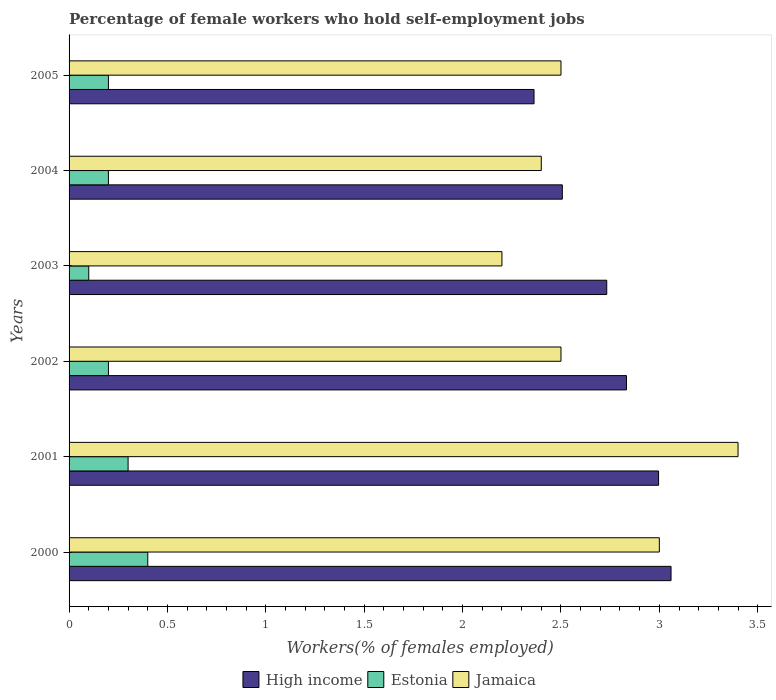How many different coloured bars are there?
Keep it short and to the point. 3. Are the number of bars on each tick of the Y-axis equal?
Your answer should be compact. Yes. How many bars are there on the 4th tick from the bottom?
Your answer should be compact. 3. In how many cases, is the number of bars for a given year not equal to the number of legend labels?
Make the answer very short. 0. What is the percentage of self-employed female workers in High income in 2005?
Offer a terse response. 2.36. Across all years, what is the maximum percentage of self-employed female workers in Estonia?
Your answer should be very brief. 0.4. Across all years, what is the minimum percentage of self-employed female workers in Jamaica?
Make the answer very short. 2.2. What is the total percentage of self-employed female workers in Jamaica in the graph?
Ensure brevity in your answer.  16. What is the difference between the percentage of self-employed female workers in Jamaica in 2004 and that in 2005?
Keep it short and to the point. -0.1. What is the difference between the percentage of self-employed female workers in High income in 2000 and the percentage of self-employed female workers in Jamaica in 2003?
Ensure brevity in your answer.  0.86. What is the average percentage of self-employed female workers in High income per year?
Give a very brief answer. 2.75. In the year 2003, what is the difference between the percentage of self-employed female workers in Estonia and percentage of self-employed female workers in High income?
Keep it short and to the point. -2.63. In how many years, is the percentage of self-employed female workers in Estonia greater than 1.1 %?
Make the answer very short. 0. What is the ratio of the percentage of self-employed female workers in High income in 2000 to that in 2005?
Offer a terse response. 1.29. Is the percentage of self-employed female workers in Jamaica in 2002 less than that in 2003?
Ensure brevity in your answer.  No. What is the difference between the highest and the second highest percentage of self-employed female workers in Estonia?
Offer a terse response. 0.1. What is the difference between the highest and the lowest percentage of self-employed female workers in Estonia?
Keep it short and to the point. 0.3. In how many years, is the percentage of self-employed female workers in Estonia greater than the average percentage of self-employed female workers in Estonia taken over all years?
Give a very brief answer. 2. What does the 1st bar from the top in 2005 represents?
Offer a terse response. Jamaica. What does the 3rd bar from the bottom in 2003 represents?
Your answer should be very brief. Jamaica. Is it the case that in every year, the sum of the percentage of self-employed female workers in Estonia and percentage of self-employed female workers in Jamaica is greater than the percentage of self-employed female workers in High income?
Keep it short and to the point. No. Are all the bars in the graph horizontal?
Offer a very short reply. Yes. What is the difference between two consecutive major ticks on the X-axis?
Provide a succinct answer. 0.5. Are the values on the major ticks of X-axis written in scientific E-notation?
Your answer should be compact. No. Does the graph contain any zero values?
Your answer should be very brief. No. Does the graph contain grids?
Ensure brevity in your answer.  No. What is the title of the graph?
Offer a very short reply. Percentage of female workers who hold self-employment jobs. Does "Netherlands" appear as one of the legend labels in the graph?
Offer a terse response. No. What is the label or title of the X-axis?
Give a very brief answer. Workers(% of females employed). What is the label or title of the Y-axis?
Your answer should be very brief. Years. What is the Workers(% of females employed) in High income in 2000?
Your response must be concise. 3.06. What is the Workers(% of females employed) in Estonia in 2000?
Ensure brevity in your answer.  0.4. What is the Workers(% of females employed) of Jamaica in 2000?
Your response must be concise. 3. What is the Workers(% of females employed) of High income in 2001?
Your answer should be compact. 3. What is the Workers(% of females employed) in Estonia in 2001?
Keep it short and to the point. 0.3. What is the Workers(% of females employed) of Jamaica in 2001?
Keep it short and to the point. 3.4. What is the Workers(% of females employed) of High income in 2002?
Make the answer very short. 2.83. What is the Workers(% of females employed) in Estonia in 2002?
Ensure brevity in your answer.  0.2. What is the Workers(% of females employed) in High income in 2003?
Ensure brevity in your answer.  2.73. What is the Workers(% of females employed) in Estonia in 2003?
Provide a short and direct response. 0.1. What is the Workers(% of females employed) in Jamaica in 2003?
Your response must be concise. 2.2. What is the Workers(% of females employed) in High income in 2004?
Provide a succinct answer. 2.51. What is the Workers(% of females employed) of Estonia in 2004?
Your answer should be compact. 0.2. What is the Workers(% of females employed) of Jamaica in 2004?
Your answer should be very brief. 2.4. What is the Workers(% of females employed) in High income in 2005?
Make the answer very short. 2.36. What is the Workers(% of females employed) in Estonia in 2005?
Ensure brevity in your answer.  0.2. What is the Workers(% of females employed) of Jamaica in 2005?
Your answer should be very brief. 2.5. Across all years, what is the maximum Workers(% of females employed) of High income?
Provide a succinct answer. 3.06. Across all years, what is the maximum Workers(% of females employed) of Estonia?
Your response must be concise. 0.4. Across all years, what is the maximum Workers(% of females employed) of Jamaica?
Make the answer very short. 3.4. Across all years, what is the minimum Workers(% of females employed) in High income?
Provide a succinct answer. 2.36. Across all years, what is the minimum Workers(% of females employed) in Estonia?
Make the answer very short. 0.1. Across all years, what is the minimum Workers(% of females employed) of Jamaica?
Your answer should be compact. 2.2. What is the total Workers(% of females employed) of High income in the graph?
Provide a succinct answer. 16.49. What is the difference between the Workers(% of females employed) in High income in 2000 and that in 2001?
Keep it short and to the point. 0.06. What is the difference between the Workers(% of females employed) of High income in 2000 and that in 2002?
Your answer should be compact. 0.23. What is the difference between the Workers(% of females employed) of Estonia in 2000 and that in 2002?
Make the answer very short. 0.2. What is the difference between the Workers(% of females employed) of Jamaica in 2000 and that in 2002?
Ensure brevity in your answer.  0.5. What is the difference between the Workers(% of females employed) in High income in 2000 and that in 2003?
Your response must be concise. 0.33. What is the difference between the Workers(% of females employed) in High income in 2000 and that in 2004?
Keep it short and to the point. 0.55. What is the difference between the Workers(% of females employed) in Estonia in 2000 and that in 2004?
Offer a terse response. 0.2. What is the difference between the Workers(% of females employed) in Jamaica in 2000 and that in 2004?
Provide a short and direct response. 0.6. What is the difference between the Workers(% of females employed) in High income in 2000 and that in 2005?
Your response must be concise. 0.7. What is the difference between the Workers(% of females employed) in Estonia in 2000 and that in 2005?
Give a very brief answer. 0.2. What is the difference between the Workers(% of females employed) of High income in 2001 and that in 2002?
Offer a very short reply. 0.16. What is the difference between the Workers(% of females employed) in Jamaica in 2001 and that in 2002?
Offer a very short reply. 0.9. What is the difference between the Workers(% of females employed) in High income in 2001 and that in 2003?
Your response must be concise. 0.26. What is the difference between the Workers(% of females employed) of High income in 2001 and that in 2004?
Provide a short and direct response. 0.49. What is the difference between the Workers(% of females employed) of High income in 2001 and that in 2005?
Your answer should be very brief. 0.63. What is the difference between the Workers(% of females employed) in Jamaica in 2001 and that in 2005?
Make the answer very short. 0.9. What is the difference between the Workers(% of females employed) of High income in 2002 and that in 2003?
Provide a short and direct response. 0.1. What is the difference between the Workers(% of females employed) of Estonia in 2002 and that in 2003?
Offer a very short reply. 0.1. What is the difference between the Workers(% of females employed) in High income in 2002 and that in 2004?
Your answer should be very brief. 0.33. What is the difference between the Workers(% of females employed) in Estonia in 2002 and that in 2004?
Your response must be concise. 0. What is the difference between the Workers(% of females employed) of Jamaica in 2002 and that in 2004?
Your answer should be very brief. 0.1. What is the difference between the Workers(% of females employed) of High income in 2002 and that in 2005?
Make the answer very short. 0.47. What is the difference between the Workers(% of females employed) in Estonia in 2002 and that in 2005?
Offer a terse response. 0. What is the difference between the Workers(% of females employed) in Jamaica in 2002 and that in 2005?
Make the answer very short. 0. What is the difference between the Workers(% of females employed) of High income in 2003 and that in 2004?
Offer a terse response. 0.23. What is the difference between the Workers(% of females employed) of Estonia in 2003 and that in 2004?
Your answer should be compact. -0.1. What is the difference between the Workers(% of females employed) in Jamaica in 2003 and that in 2004?
Offer a very short reply. -0.2. What is the difference between the Workers(% of females employed) of High income in 2003 and that in 2005?
Your response must be concise. 0.37. What is the difference between the Workers(% of females employed) of High income in 2004 and that in 2005?
Provide a short and direct response. 0.14. What is the difference between the Workers(% of females employed) of High income in 2000 and the Workers(% of females employed) of Estonia in 2001?
Provide a short and direct response. 2.76. What is the difference between the Workers(% of females employed) in High income in 2000 and the Workers(% of females employed) in Jamaica in 2001?
Your answer should be very brief. -0.34. What is the difference between the Workers(% of females employed) of High income in 2000 and the Workers(% of females employed) of Estonia in 2002?
Your answer should be very brief. 2.86. What is the difference between the Workers(% of females employed) in High income in 2000 and the Workers(% of females employed) in Jamaica in 2002?
Provide a short and direct response. 0.56. What is the difference between the Workers(% of females employed) of Estonia in 2000 and the Workers(% of females employed) of Jamaica in 2002?
Your answer should be compact. -2.1. What is the difference between the Workers(% of females employed) of High income in 2000 and the Workers(% of females employed) of Estonia in 2003?
Offer a terse response. 2.96. What is the difference between the Workers(% of females employed) in High income in 2000 and the Workers(% of females employed) in Jamaica in 2003?
Make the answer very short. 0.86. What is the difference between the Workers(% of females employed) in High income in 2000 and the Workers(% of females employed) in Estonia in 2004?
Your response must be concise. 2.86. What is the difference between the Workers(% of females employed) of High income in 2000 and the Workers(% of females employed) of Jamaica in 2004?
Keep it short and to the point. 0.66. What is the difference between the Workers(% of females employed) of High income in 2000 and the Workers(% of females employed) of Estonia in 2005?
Provide a succinct answer. 2.86. What is the difference between the Workers(% of females employed) of High income in 2000 and the Workers(% of females employed) of Jamaica in 2005?
Give a very brief answer. 0.56. What is the difference between the Workers(% of females employed) of Estonia in 2000 and the Workers(% of females employed) of Jamaica in 2005?
Offer a very short reply. -2.1. What is the difference between the Workers(% of females employed) in High income in 2001 and the Workers(% of females employed) in Estonia in 2002?
Provide a succinct answer. 2.8. What is the difference between the Workers(% of females employed) of High income in 2001 and the Workers(% of females employed) of Jamaica in 2002?
Your answer should be compact. 0.5. What is the difference between the Workers(% of females employed) in Estonia in 2001 and the Workers(% of females employed) in Jamaica in 2002?
Offer a very short reply. -2.2. What is the difference between the Workers(% of females employed) in High income in 2001 and the Workers(% of females employed) in Estonia in 2003?
Offer a terse response. 2.9. What is the difference between the Workers(% of females employed) in High income in 2001 and the Workers(% of females employed) in Jamaica in 2003?
Keep it short and to the point. 0.8. What is the difference between the Workers(% of females employed) in Estonia in 2001 and the Workers(% of females employed) in Jamaica in 2003?
Your answer should be compact. -1.9. What is the difference between the Workers(% of females employed) in High income in 2001 and the Workers(% of females employed) in Estonia in 2004?
Offer a terse response. 2.8. What is the difference between the Workers(% of females employed) in High income in 2001 and the Workers(% of females employed) in Jamaica in 2004?
Make the answer very short. 0.6. What is the difference between the Workers(% of females employed) of Estonia in 2001 and the Workers(% of females employed) of Jamaica in 2004?
Give a very brief answer. -2.1. What is the difference between the Workers(% of females employed) in High income in 2001 and the Workers(% of females employed) in Estonia in 2005?
Offer a very short reply. 2.8. What is the difference between the Workers(% of females employed) of High income in 2001 and the Workers(% of females employed) of Jamaica in 2005?
Provide a short and direct response. 0.5. What is the difference between the Workers(% of females employed) of High income in 2002 and the Workers(% of females employed) of Estonia in 2003?
Offer a very short reply. 2.73. What is the difference between the Workers(% of females employed) in High income in 2002 and the Workers(% of females employed) in Jamaica in 2003?
Make the answer very short. 0.63. What is the difference between the Workers(% of females employed) of High income in 2002 and the Workers(% of females employed) of Estonia in 2004?
Make the answer very short. 2.63. What is the difference between the Workers(% of females employed) in High income in 2002 and the Workers(% of females employed) in Jamaica in 2004?
Ensure brevity in your answer.  0.43. What is the difference between the Workers(% of females employed) in Estonia in 2002 and the Workers(% of females employed) in Jamaica in 2004?
Your answer should be very brief. -2.2. What is the difference between the Workers(% of females employed) of High income in 2002 and the Workers(% of females employed) of Estonia in 2005?
Provide a short and direct response. 2.63. What is the difference between the Workers(% of females employed) of High income in 2002 and the Workers(% of females employed) of Jamaica in 2005?
Keep it short and to the point. 0.33. What is the difference between the Workers(% of females employed) of High income in 2003 and the Workers(% of females employed) of Estonia in 2004?
Make the answer very short. 2.53. What is the difference between the Workers(% of females employed) in High income in 2003 and the Workers(% of females employed) in Jamaica in 2004?
Give a very brief answer. 0.33. What is the difference between the Workers(% of females employed) in Estonia in 2003 and the Workers(% of females employed) in Jamaica in 2004?
Your response must be concise. -2.3. What is the difference between the Workers(% of females employed) of High income in 2003 and the Workers(% of females employed) of Estonia in 2005?
Your answer should be compact. 2.53. What is the difference between the Workers(% of females employed) in High income in 2003 and the Workers(% of females employed) in Jamaica in 2005?
Your response must be concise. 0.23. What is the difference between the Workers(% of females employed) of High income in 2004 and the Workers(% of females employed) of Estonia in 2005?
Provide a succinct answer. 2.31. What is the difference between the Workers(% of females employed) in High income in 2004 and the Workers(% of females employed) in Jamaica in 2005?
Keep it short and to the point. 0.01. What is the average Workers(% of females employed) of High income per year?
Make the answer very short. 2.75. What is the average Workers(% of females employed) in Estonia per year?
Keep it short and to the point. 0.23. What is the average Workers(% of females employed) of Jamaica per year?
Your response must be concise. 2.67. In the year 2000, what is the difference between the Workers(% of females employed) of High income and Workers(% of females employed) of Estonia?
Keep it short and to the point. 2.66. In the year 2000, what is the difference between the Workers(% of females employed) in High income and Workers(% of females employed) in Jamaica?
Make the answer very short. 0.06. In the year 2000, what is the difference between the Workers(% of females employed) of Estonia and Workers(% of females employed) of Jamaica?
Give a very brief answer. -2.6. In the year 2001, what is the difference between the Workers(% of females employed) of High income and Workers(% of females employed) of Estonia?
Keep it short and to the point. 2.7. In the year 2001, what is the difference between the Workers(% of females employed) of High income and Workers(% of females employed) of Jamaica?
Make the answer very short. -0.4. In the year 2001, what is the difference between the Workers(% of females employed) of Estonia and Workers(% of females employed) of Jamaica?
Make the answer very short. -3.1. In the year 2002, what is the difference between the Workers(% of females employed) in High income and Workers(% of females employed) in Estonia?
Your answer should be very brief. 2.63. In the year 2002, what is the difference between the Workers(% of females employed) of High income and Workers(% of females employed) of Jamaica?
Your answer should be very brief. 0.33. In the year 2002, what is the difference between the Workers(% of females employed) in Estonia and Workers(% of females employed) in Jamaica?
Keep it short and to the point. -2.3. In the year 2003, what is the difference between the Workers(% of females employed) of High income and Workers(% of females employed) of Estonia?
Offer a very short reply. 2.63. In the year 2003, what is the difference between the Workers(% of females employed) in High income and Workers(% of females employed) in Jamaica?
Your response must be concise. 0.53. In the year 2004, what is the difference between the Workers(% of females employed) in High income and Workers(% of females employed) in Estonia?
Make the answer very short. 2.31. In the year 2004, what is the difference between the Workers(% of females employed) of High income and Workers(% of females employed) of Jamaica?
Keep it short and to the point. 0.11. In the year 2004, what is the difference between the Workers(% of females employed) of Estonia and Workers(% of females employed) of Jamaica?
Your response must be concise. -2.2. In the year 2005, what is the difference between the Workers(% of females employed) of High income and Workers(% of females employed) of Estonia?
Offer a very short reply. 2.16. In the year 2005, what is the difference between the Workers(% of females employed) in High income and Workers(% of females employed) in Jamaica?
Ensure brevity in your answer.  -0.14. What is the ratio of the Workers(% of females employed) in High income in 2000 to that in 2001?
Make the answer very short. 1.02. What is the ratio of the Workers(% of females employed) of Estonia in 2000 to that in 2001?
Provide a succinct answer. 1.33. What is the ratio of the Workers(% of females employed) of Jamaica in 2000 to that in 2001?
Your response must be concise. 0.88. What is the ratio of the Workers(% of females employed) of High income in 2000 to that in 2002?
Give a very brief answer. 1.08. What is the ratio of the Workers(% of females employed) in Estonia in 2000 to that in 2002?
Provide a succinct answer. 2. What is the ratio of the Workers(% of females employed) in High income in 2000 to that in 2003?
Give a very brief answer. 1.12. What is the ratio of the Workers(% of females employed) of Estonia in 2000 to that in 2003?
Your answer should be compact. 4. What is the ratio of the Workers(% of females employed) of Jamaica in 2000 to that in 2003?
Offer a terse response. 1.36. What is the ratio of the Workers(% of females employed) of High income in 2000 to that in 2004?
Your response must be concise. 1.22. What is the ratio of the Workers(% of females employed) in Jamaica in 2000 to that in 2004?
Your answer should be compact. 1.25. What is the ratio of the Workers(% of females employed) of High income in 2000 to that in 2005?
Your response must be concise. 1.29. What is the ratio of the Workers(% of females employed) of Jamaica in 2000 to that in 2005?
Make the answer very short. 1.2. What is the ratio of the Workers(% of females employed) of High income in 2001 to that in 2002?
Make the answer very short. 1.06. What is the ratio of the Workers(% of females employed) of Jamaica in 2001 to that in 2002?
Your answer should be compact. 1.36. What is the ratio of the Workers(% of females employed) of High income in 2001 to that in 2003?
Give a very brief answer. 1.1. What is the ratio of the Workers(% of females employed) in Jamaica in 2001 to that in 2003?
Provide a succinct answer. 1.55. What is the ratio of the Workers(% of females employed) in High income in 2001 to that in 2004?
Offer a very short reply. 1.2. What is the ratio of the Workers(% of females employed) of Estonia in 2001 to that in 2004?
Keep it short and to the point. 1.5. What is the ratio of the Workers(% of females employed) in Jamaica in 2001 to that in 2004?
Your answer should be very brief. 1.42. What is the ratio of the Workers(% of females employed) in High income in 2001 to that in 2005?
Your answer should be compact. 1.27. What is the ratio of the Workers(% of females employed) in Estonia in 2001 to that in 2005?
Offer a terse response. 1.5. What is the ratio of the Workers(% of females employed) of Jamaica in 2001 to that in 2005?
Your answer should be very brief. 1.36. What is the ratio of the Workers(% of females employed) of High income in 2002 to that in 2003?
Your answer should be compact. 1.04. What is the ratio of the Workers(% of females employed) in Jamaica in 2002 to that in 2003?
Offer a very short reply. 1.14. What is the ratio of the Workers(% of females employed) in High income in 2002 to that in 2004?
Your answer should be compact. 1.13. What is the ratio of the Workers(% of females employed) in Jamaica in 2002 to that in 2004?
Provide a short and direct response. 1.04. What is the ratio of the Workers(% of females employed) of High income in 2002 to that in 2005?
Provide a short and direct response. 1.2. What is the ratio of the Workers(% of females employed) of Estonia in 2002 to that in 2005?
Keep it short and to the point. 1. What is the ratio of the Workers(% of females employed) in High income in 2003 to that in 2004?
Your answer should be very brief. 1.09. What is the ratio of the Workers(% of females employed) of Jamaica in 2003 to that in 2004?
Your answer should be compact. 0.92. What is the ratio of the Workers(% of females employed) in High income in 2003 to that in 2005?
Keep it short and to the point. 1.16. What is the ratio of the Workers(% of females employed) of Jamaica in 2003 to that in 2005?
Keep it short and to the point. 0.88. What is the ratio of the Workers(% of females employed) of High income in 2004 to that in 2005?
Provide a short and direct response. 1.06. What is the ratio of the Workers(% of females employed) in Estonia in 2004 to that in 2005?
Ensure brevity in your answer.  1. What is the difference between the highest and the second highest Workers(% of females employed) of High income?
Keep it short and to the point. 0.06. What is the difference between the highest and the lowest Workers(% of females employed) in High income?
Keep it short and to the point. 0.7. What is the difference between the highest and the lowest Workers(% of females employed) in Jamaica?
Make the answer very short. 1.2. 